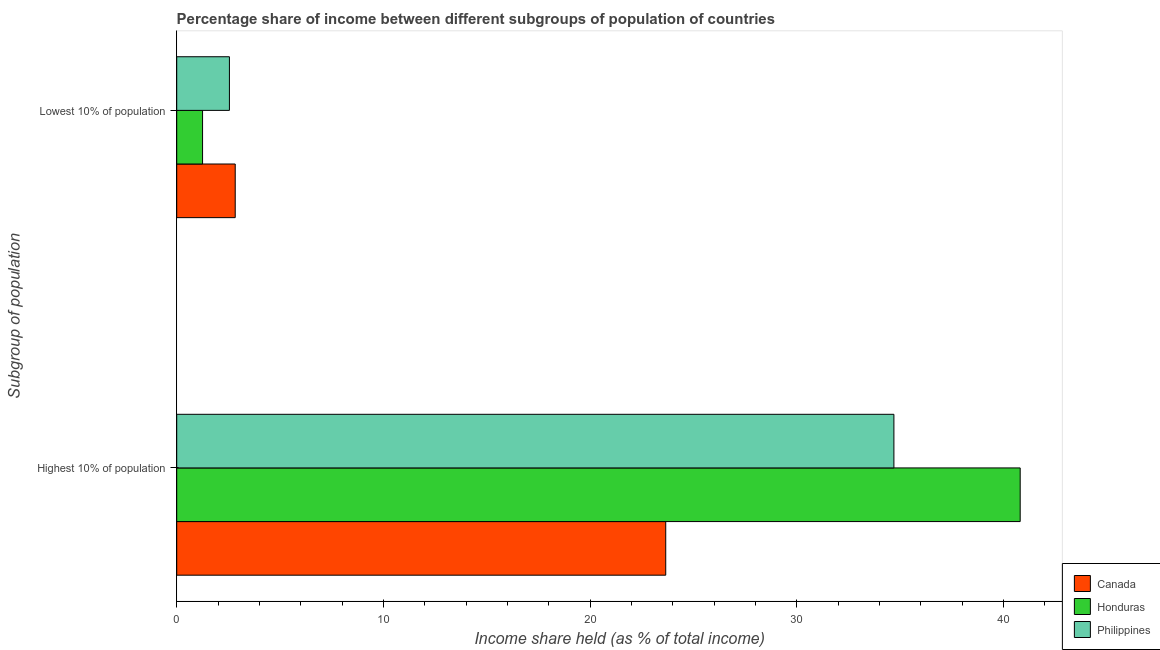How many different coloured bars are there?
Your answer should be very brief. 3. How many groups of bars are there?
Keep it short and to the point. 2. Are the number of bars per tick equal to the number of legend labels?
Offer a terse response. Yes. Are the number of bars on each tick of the Y-axis equal?
Offer a very short reply. Yes. What is the label of the 1st group of bars from the top?
Offer a terse response. Lowest 10% of population. What is the income share held by highest 10% of the population in Canada?
Keep it short and to the point. 23.66. Across all countries, what is the maximum income share held by lowest 10% of the population?
Your answer should be very brief. 2.83. Across all countries, what is the minimum income share held by highest 10% of the population?
Provide a short and direct response. 23.66. In which country was the income share held by highest 10% of the population maximum?
Give a very brief answer. Honduras. What is the total income share held by highest 10% of the population in the graph?
Make the answer very short. 99.17. What is the difference between the income share held by lowest 10% of the population in Honduras and that in Canada?
Provide a short and direct response. -1.58. What is the difference between the income share held by lowest 10% of the population in Canada and the income share held by highest 10% of the population in Honduras?
Make the answer very short. -37.98. What is the average income share held by highest 10% of the population per country?
Your response must be concise. 33.06. What is the difference between the income share held by highest 10% of the population and income share held by lowest 10% of the population in Canada?
Make the answer very short. 20.83. What is the ratio of the income share held by lowest 10% of the population in Canada to that in Philippines?
Ensure brevity in your answer.  1.11. Is the income share held by highest 10% of the population in Canada less than that in Philippines?
Keep it short and to the point. Yes. What does the 2nd bar from the top in Highest 10% of population represents?
Provide a succinct answer. Honduras. What does the 2nd bar from the bottom in Lowest 10% of population represents?
Offer a very short reply. Honduras. How many bars are there?
Ensure brevity in your answer.  6. Are all the bars in the graph horizontal?
Make the answer very short. Yes. What is the difference between two consecutive major ticks on the X-axis?
Your answer should be very brief. 10. Does the graph contain any zero values?
Make the answer very short. No. Does the graph contain grids?
Provide a short and direct response. No. Where does the legend appear in the graph?
Keep it short and to the point. Bottom right. How many legend labels are there?
Provide a succinct answer. 3. How are the legend labels stacked?
Give a very brief answer. Vertical. What is the title of the graph?
Ensure brevity in your answer.  Percentage share of income between different subgroups of population of countries. What is the label or title of the X-axis?
Offer a terse response. Income share held (as % of total income). What is the label or title of the Y-axis?
Make the answer very short. Subgroup of population. What is the Income share held (as % of total income) of Canada in Highest 10% of population?
Give a very brief answer. 23.66. What is the Income share held (as % of total income) of Honduras in Highest 10% of population?
Offer a very short reply. 40.81. What is the Income share held (as % of total income) of Philippines in Highest 10% of population?
Offer a terse response. 34.7. What is the Income share held (as % of total income) in Canada in Lowest 10% of population?
Your answer should be very brief. 2.83. What is the Income share held (as % of total income) in Honduras in Lowest 10% of population?
Make the answer very short. 1.25. What is the Income share held (as % of total income) in Philippines in Lowest 10% of population?
Your answer should be very brief. 2.55. Across all Subgroup of population, what is the maximum Income share held (as % of total income) of Canada?
Offer a terse response. 23.66. Across all Subgroup of population, what is the maximum Income share held (as % of total income) in Honduras?
Give a very brief answer. 40.81. Across all Subgroup of population, what is the maximum Income share held (as % of total income) in Philippines?
Make the answer very short. 34.7. Across all Subgroup of population, what is the minimum Income share held (as % of total income) of Canada?
Keep it short and to the point. 2.83. Across all Subgroup of population, what is the minimum Income share held (as % of total income) in Philippines?
Give a very brief answer. 2.55. What is the total Income share held (as % of total income) of Canada in the graph?
Ensure brevity in your answer.  26.49. What is the total Income share held (as % of total income) in Honduras in the graph?
Offer a terse response. 42.06. What is the total Income share held (as % of total income) in Philippines in the graph?
Ensure brevity in your answer.  37.25. What is the difference between the Income share held (as % of total income) in Canada in Highest 10% of population and that in Lowest 10% of population?
Offer a very short reply. 20.83. What is the difference between the Income share held (as % of total income) in Honduras in Highest 10% of population and that in Lowest 10% of population?
Your answer should be very brief. 39.56. What is the difference between the Income share held (as % of total income) in Philippines in Highest 10% of population and that in Lowest 10% of population?
Provide a short and direct response. 32.15. What is the difference between the Income share held (as % of total income) of Canada in Highest 10% of population and the Income share held (as % of total income) of Honduras in Lowest 10% of population?
Give a very brief answer. 22.41. What is the difference between the Income share held (as % of total income) in Canada in Highest 10% of population and the Income share held (as % of total income) in Philippines in Lowest 10% of population?
Your answer should be very brief. 21.11. What is the difference between the Income share held (as % of total income) of Honduras in Highest 10% of population and the Income share held (as % of total income) of Philippines in Lowest 10% of population?
Provide a short and direct response. 38.26. What is the average Income share held (as % of total income) in Canada per Subgroup of population?
Your response must be concise. 13.24. What is the average Income share held (as % of total income) of Honduras per Subgroup of population?
Offer a terse response. 21.03. What is the average Income share held (as % of total income) of Philippines per Subgroup of population?
Provide a short and direct response. 18.62. What is the difference between the Income share held (as % of total income) in Canada and Income share held (as % of total income) in Honduras in Highest 10% of population?
Make the answer very short. -17.15. What is the difference between the Income share held (as % of total income) in Canada and Income share held (as % of total income) in Philippines in Highest 10% of population?
Keep it short and to the point. -11.04. What is the difference between the Income share held (as % of total income) of Honduras and Income share held (as % of total income) of Philippines in Highest 10% of population?
Your answer should be compact. 6.11. What is the difference between the Income share held (as % of total income) in Canada and Income share held (as % of total income) in Honduras in Lowest 10% of population?
Give a very brief answer. 1.58. What is the difference between the Income share held (as % of total income) in Canada and Income share held (as % of total income) in Philippines in Lowest 10% of population?
Keep it short and to the point. 0.28. What is the difference between the Income share held (as % of total income) in Honduras and Income share held (as % of total income) in Philippines in Lowest 10% of population?
Your response must be concise. -1.3. What is the ratio of the Income share held (as % of total income) of Canada in Highest 10% of population to that in Lowest 10% of population?
Provide a succinct answer. 8.36. What is the ratio of the Income share held (as % of total income) of Honduras in Highest 10% of population to that in Lowest 10% of population?
Keep it short and to the point. 32.65. What is the ratio of the Income share held (as % of total income) in Philippines in Highest 10% of population to that in Lowest 10% of population?
Make the answer very short. 13.61. What is the difference between the highest and the second highest Income share held (as % of total income) of Canada?
Your answer should be very brief. 20.83. What is the difference between the highest and the second highest Income share held (as % of total income) of Honduras?
Provide a succinct answer. 39.56. What is the difference between the highest and the second highest Income share held (as % of total income) in Philippines?
Your answer should be very brief. 32.15. What is the difference between the highest and the lowest Income share held (as % of total income) of Canada?
Make the answer very short. 20.83. What is the difference between the highest and the lowest Income share held (as % of total income) in Honduras?
Keep it short and to the point. 39.56. What is the difference between the highest and the lowest Income share held (as % of total income) of Philippines?
Your answer should be very brief. 32.15. 